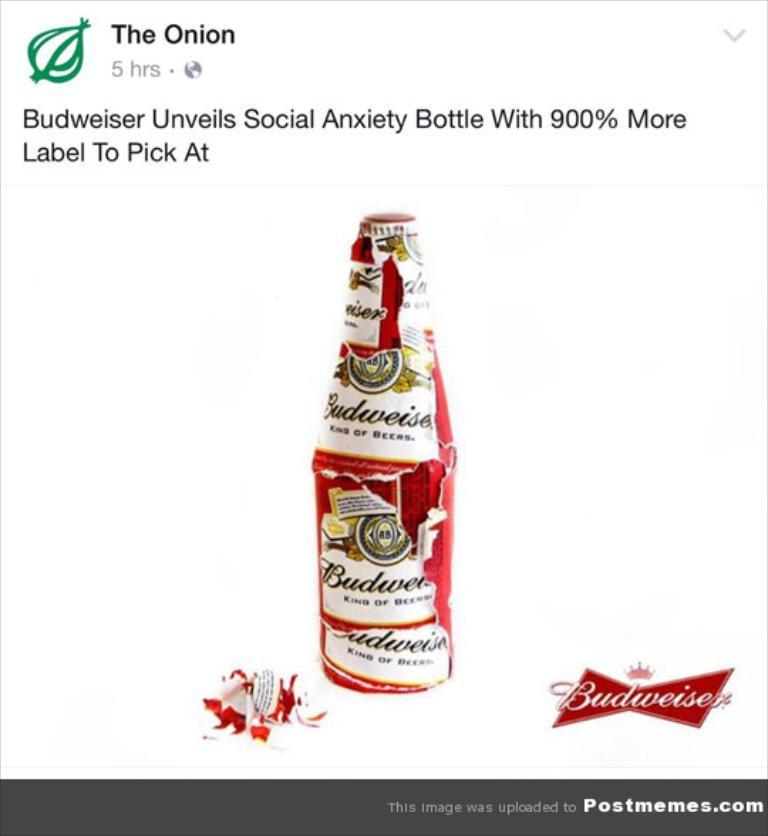<image>
Share a concise interpretation of the image provided. Budweiser Beer bottle with a Budweiser logo and design, post from The Onion 5 hrs ago. 